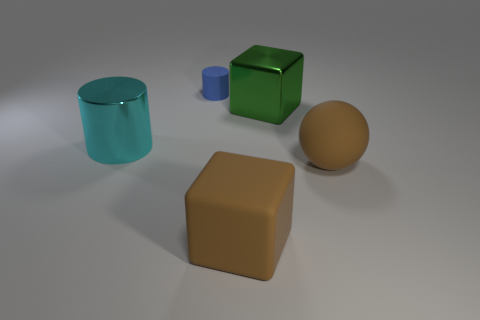Add 4 large green blocks. How many objects exist? 9 Subtract all spheres. How many objects are left? 4 Subtract all large green cubes. Subtract all brown matte objects. How many objects are left? 2 Add 5 rubber things. How many rubber things are left? 8 Add 3 metal things. How many metal things exist? 5 Subtract 0 brown cylinders. How many objects are left? 5 